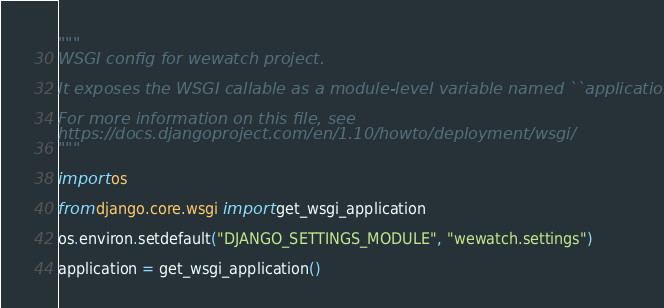<code> <loc_0><loc_0><loc_500><loc_500><_Python_>"""
WSGI config for wewatch project.

It exposes the WSGI callable as a module-level variable named ``application``.

For more information on this file, see
https://docs.djangoproject.com/en/1.10/howto/deployment/wsgi/
"""

import os

from django.core.wsgi import get_wsgi_application

os.environ.setdefault("DJANGO_SETTINGS_MODULE", "wewatch.settings")

application = get_wsgi_application()
</code> 